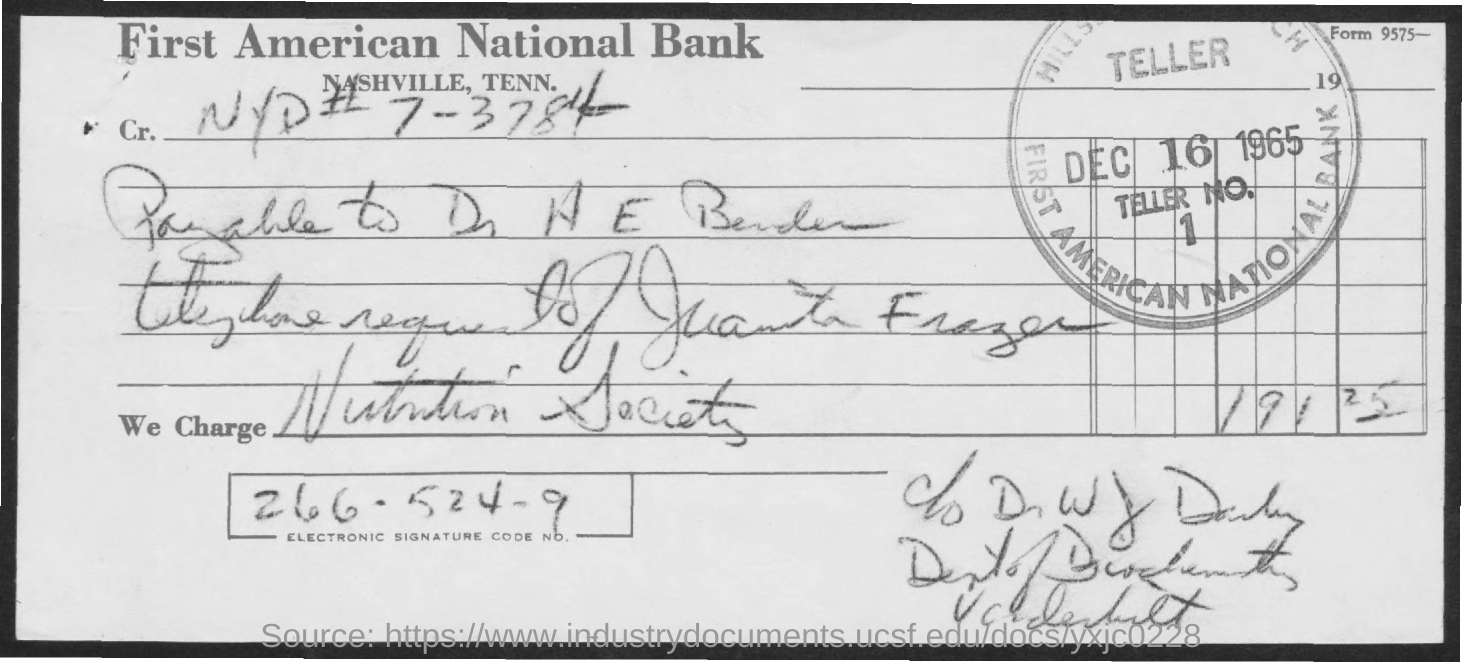What is the date on the document?
Make the answer very short. DEC 16 1965. Who is being charged?
Make the answer very short. Nutrition Society. What is the Electronic Signature Code No.?
Ensure brevity in your answer.  266.524-9. What is the Amount?
Give a very brief answer. 191 25. 